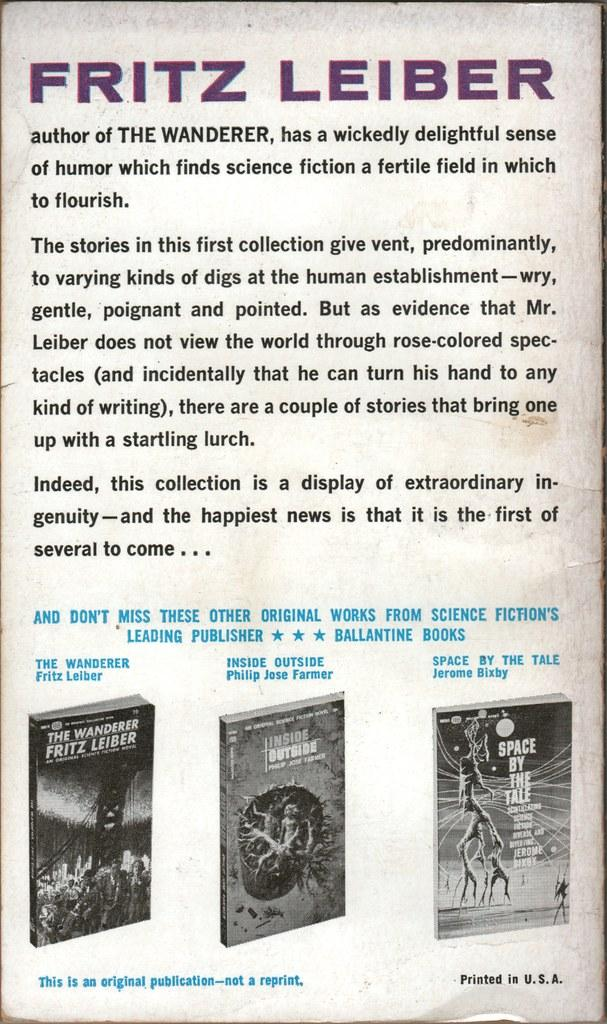<image>
Give a short and clear explanation of the subsequent image. Page that says Fritz Leiber in purple on top and a photo of three books on the bottom. 